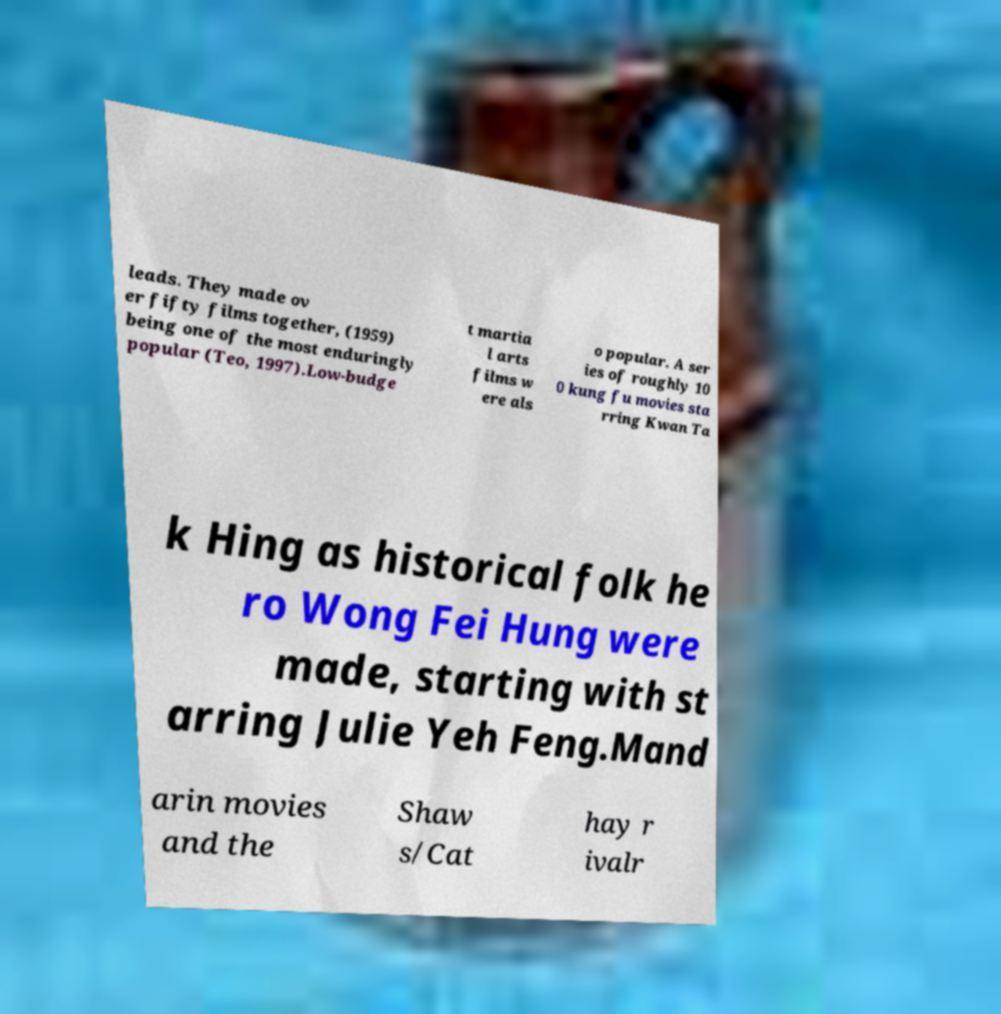What messages or text are displayed in this image? I need them in a readable, typed format. leads. They made ov er fifty films together, (1959) being one of the most enduringly popular (Teo, 1997).Low-budge t martia l arts films w ere als o popular. A ser ies of roughly 10 0 kung fu movies sta rring Kwan Ta k Hing as historical folk he ro Wong Fei Hung were made, starting with st arring Julie Yeh Feng.Mand arin movies and the Shaw s/Cat hay r ivalr 